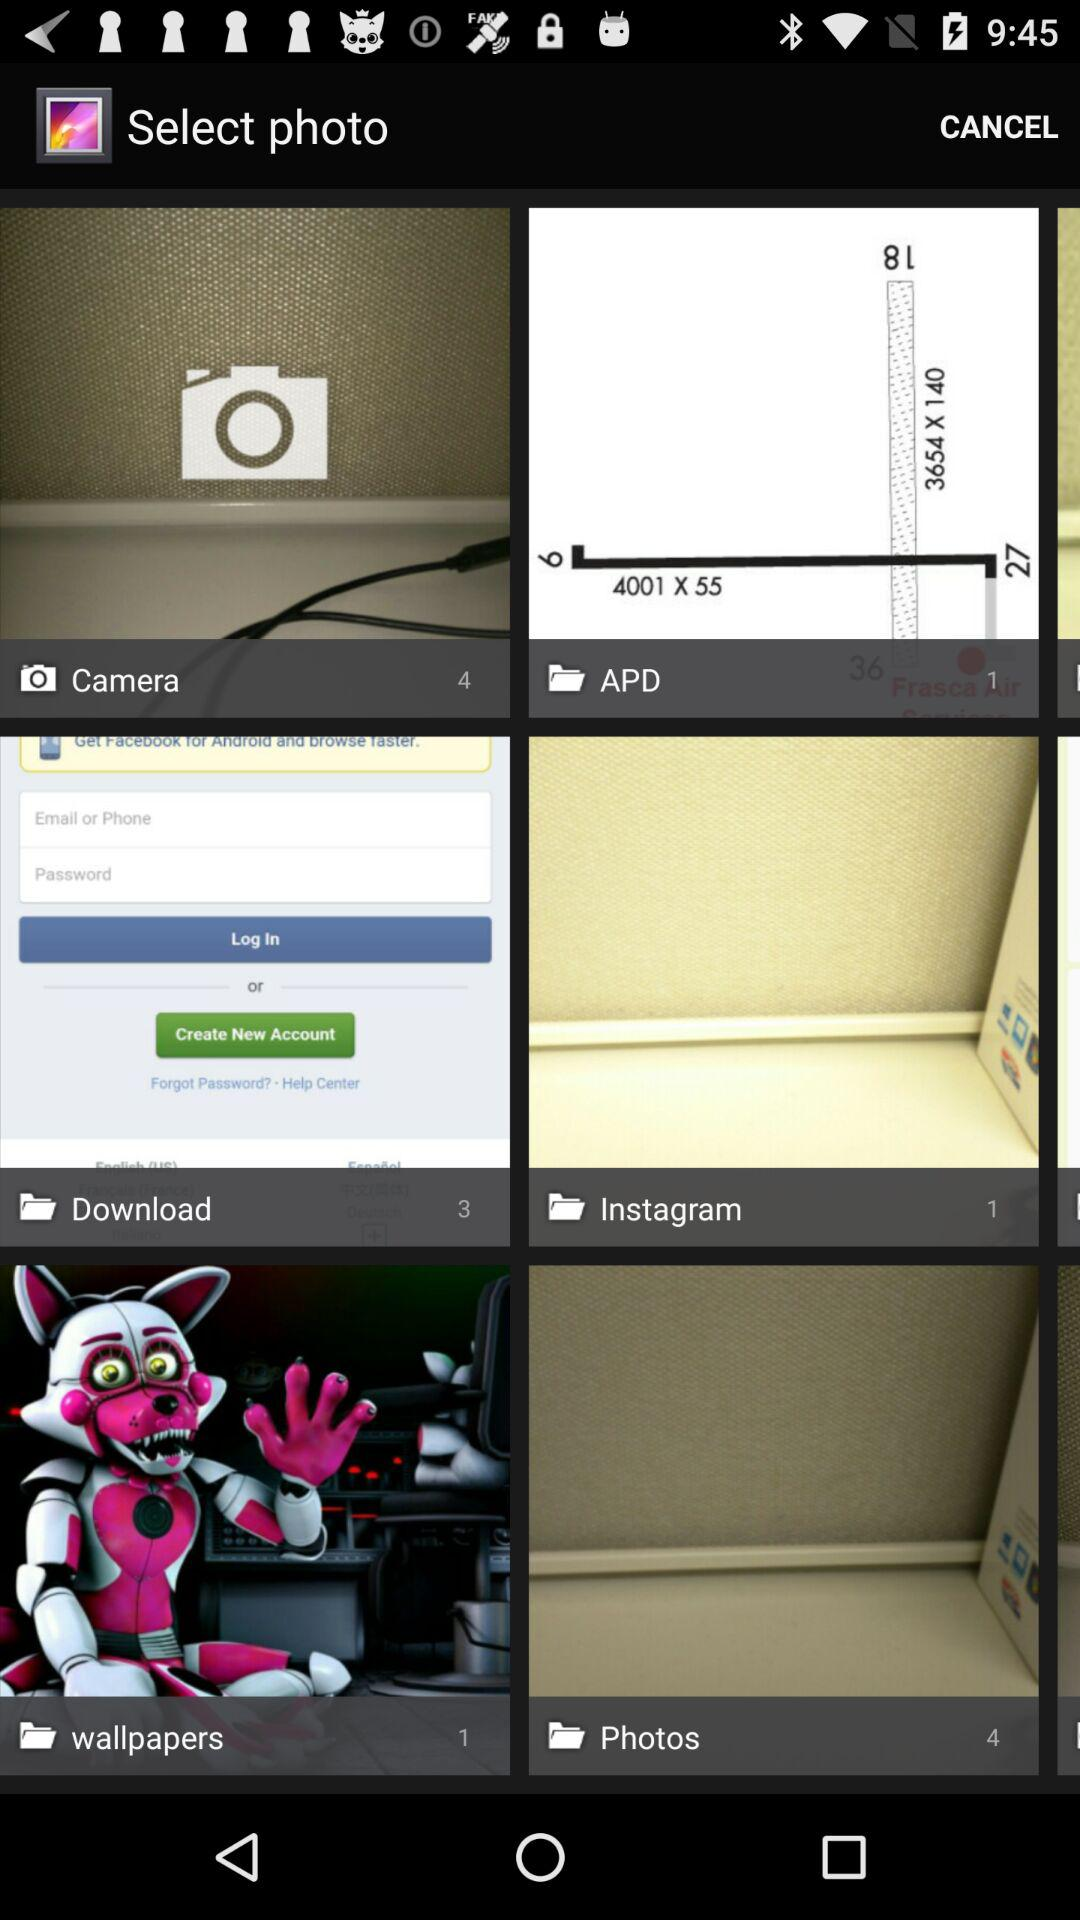What is the number available in the photos folder? The number available is 4. 